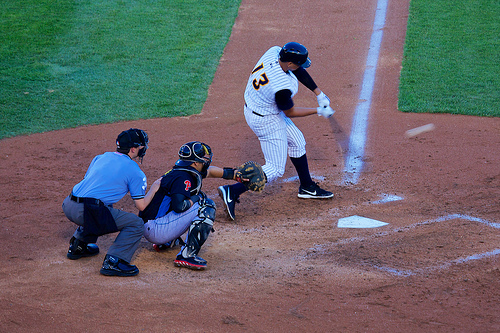Is the person with the helmet wearing a uniform? No, the person with the helmet is not wearing a traditional uniform; they are in practice or casual play attire. 